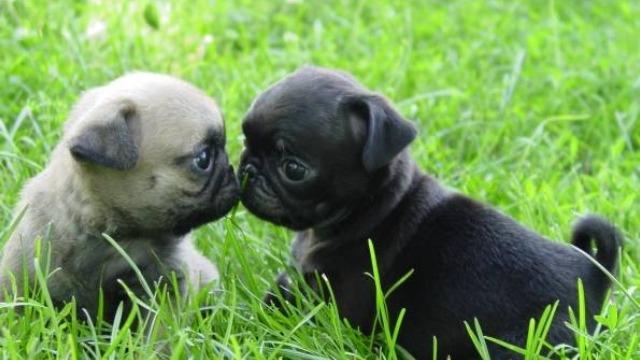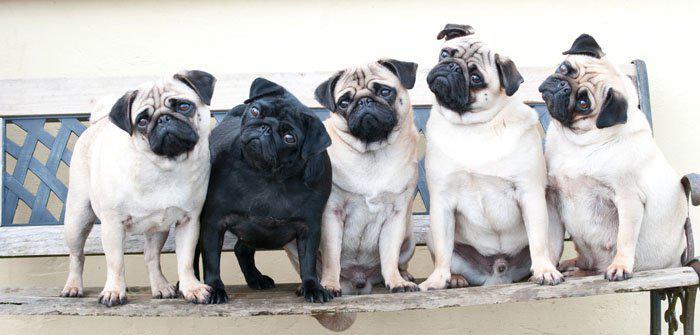The first image is the image on the left, the second image is the image on the right. Evaluate the accuracy of this statement regarding the images: "At least one dog is sleeping.". Is it true? Answer yes or no. No. The first image is the image on the left, the second image is the image on the right. Considering the images on both sides, is "there are pugs with harnesses on" valid? Answer yes or no. No. 